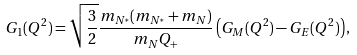Convert formula to latex. <formula><loc_0><loc_0><loc_500><loc_500>G _ { 1 } ( Q ^ { 2 } ) = \sqrt { \frac { 3 } { 2 } } \frac { m _ { N ^ { * } } ( m _ { N ^ { * } } + m _ { N } ) } { m _ { N } Q _ { + } } \left ( G _ { M } ( Q ^ { 2 } ) - G _ { E } ( Q ^ { 2 } ) \right ) ,</formula> 